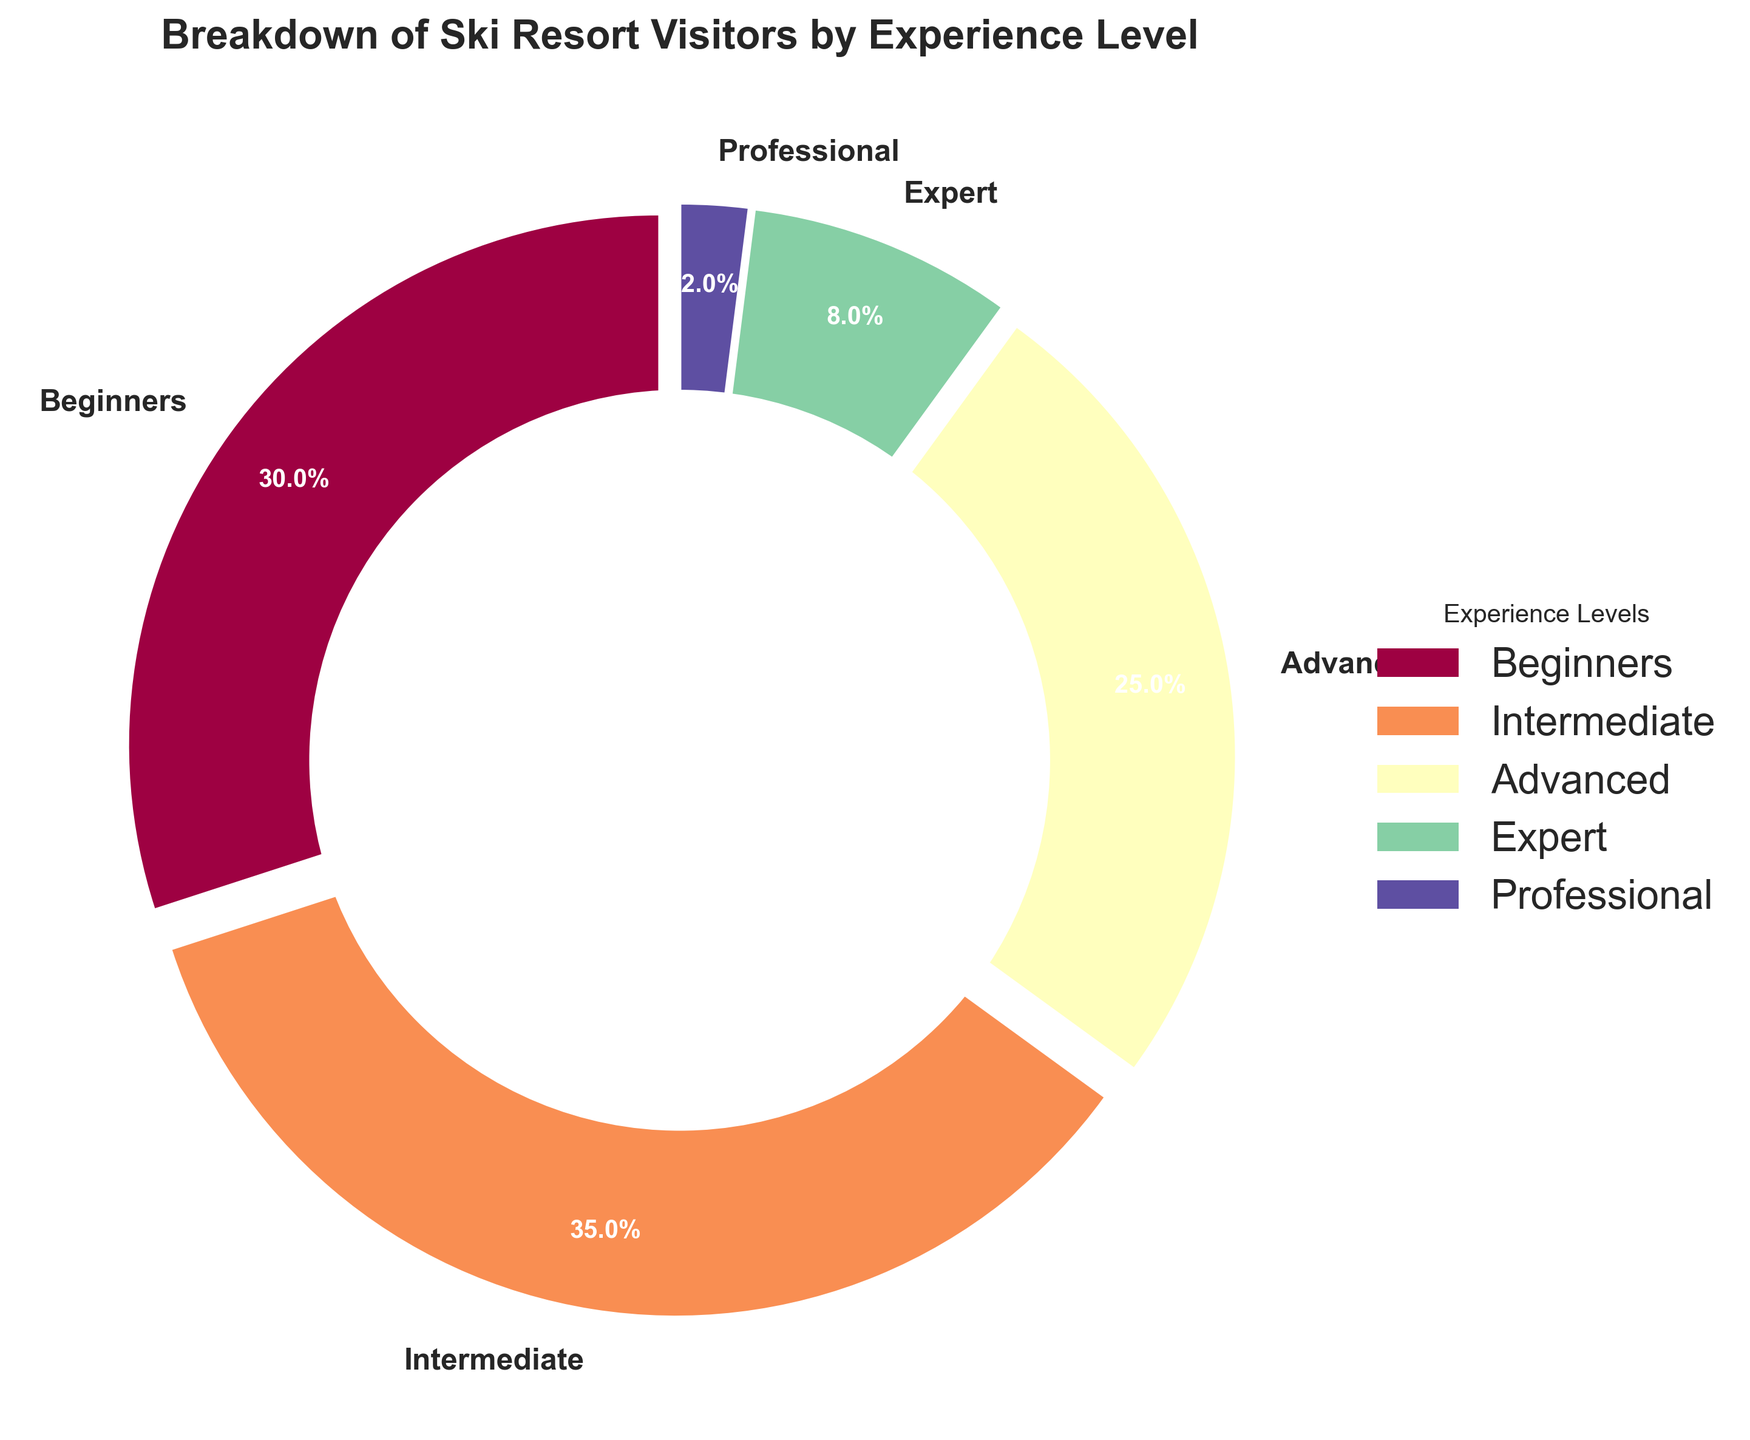Which experience level has the highest percentage of visitors? To find the experience level with the highest percentage, look at the chart and identify the largest segment. The segment labeled "Intermediate" at 35% is the largest one.
Answer: Intermediate Which two experience levels, when combined, make up the majority of visitors? To determine which two experience levels combined exceed 50%, compare all possible pairs. Beginners (30%) and Intermediate (35%) together make 65%, which is the majority.
Answer: Beginners and Intermediate What is the difference in percentage between Advanced and Expert visitors? Subtract the percentage of Expert visitors (8%) from the percentage of Advanced visitors (25%). This gives 25% - 8% = 17%.
Answer: 17% What percentage of visitors are either Professionals or Experts? Add the percentages of Professionals (2%) and Experts (8%). This results in 2% + 8% = 10%.
Answer: 10% How much more experienced are Intermediate visitors compared to Beginners? Subtract the percentage of Beginners (30%) from the percentage of Intermediate (35%). This gives 35% - 30% = 5%.
Answer: 5% Which experience levels together contribute to less than one-third of the visitors? Identify the experience levels whose combined percentages are less than 33.3%. Professional (2%) + Expert (8%), which equals 10%.
Answer: Expert and Professional What fraction of the visitors are Advanced skiers? The Advanced segment is 25% of the total visitors. Converting this to a fraction gives 25 out of 100, simplified to 1/4.
Answer: 1/4 How does the percentage of Beginners compare to that of the Professional level combined with Expert? Add the percentages of Expert (8%) and Professional (2%), which equals 10%. The percentage of Beginners is 30%, so Beginners are 30% compared to the 10% of combined Professional and Expert.
Answer: 3 times more How many times larger is the Beginner segment compared to the Professional segment? Divide the percentage of Beginners (30%) by the percentage of Professionals (2%). 30% / 2% equals 15. So, the Beginner segment is 15 times larger.
Answer: 15 times 